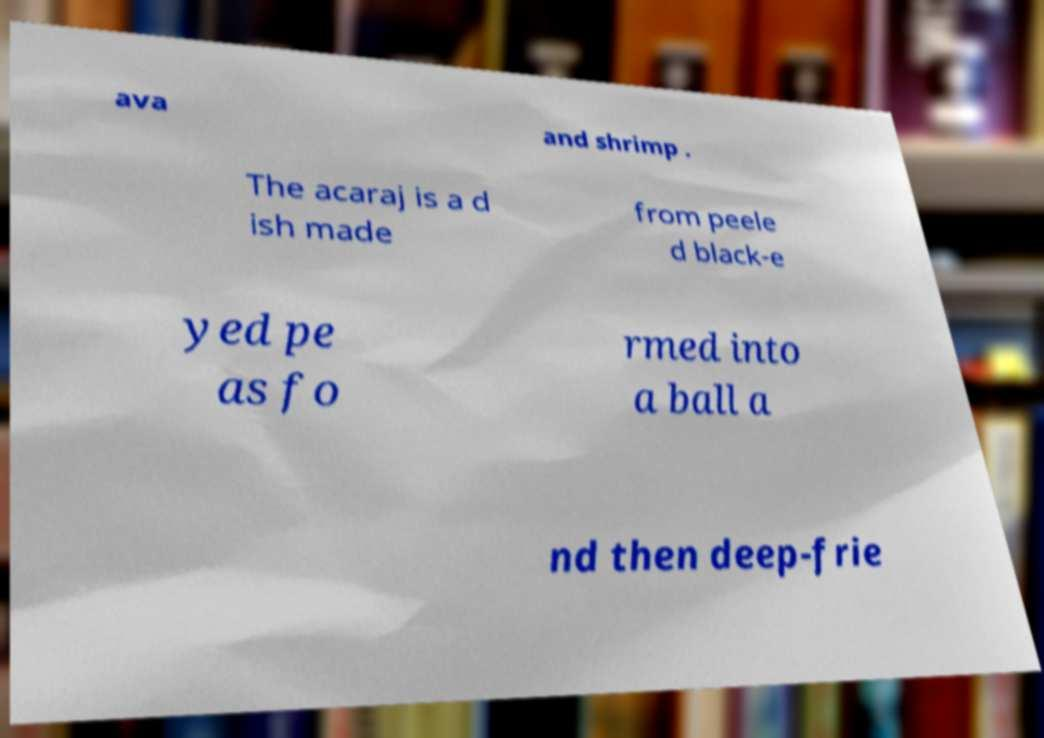Can you read and provide the text displayed in the image?This photo seems to have some interesting text. Can you extract and type it out for me? ava and shrimp . The acaraj is a d ish made from peele d black-e yed pe as fo rmed into a ball a nd then deep-frie 